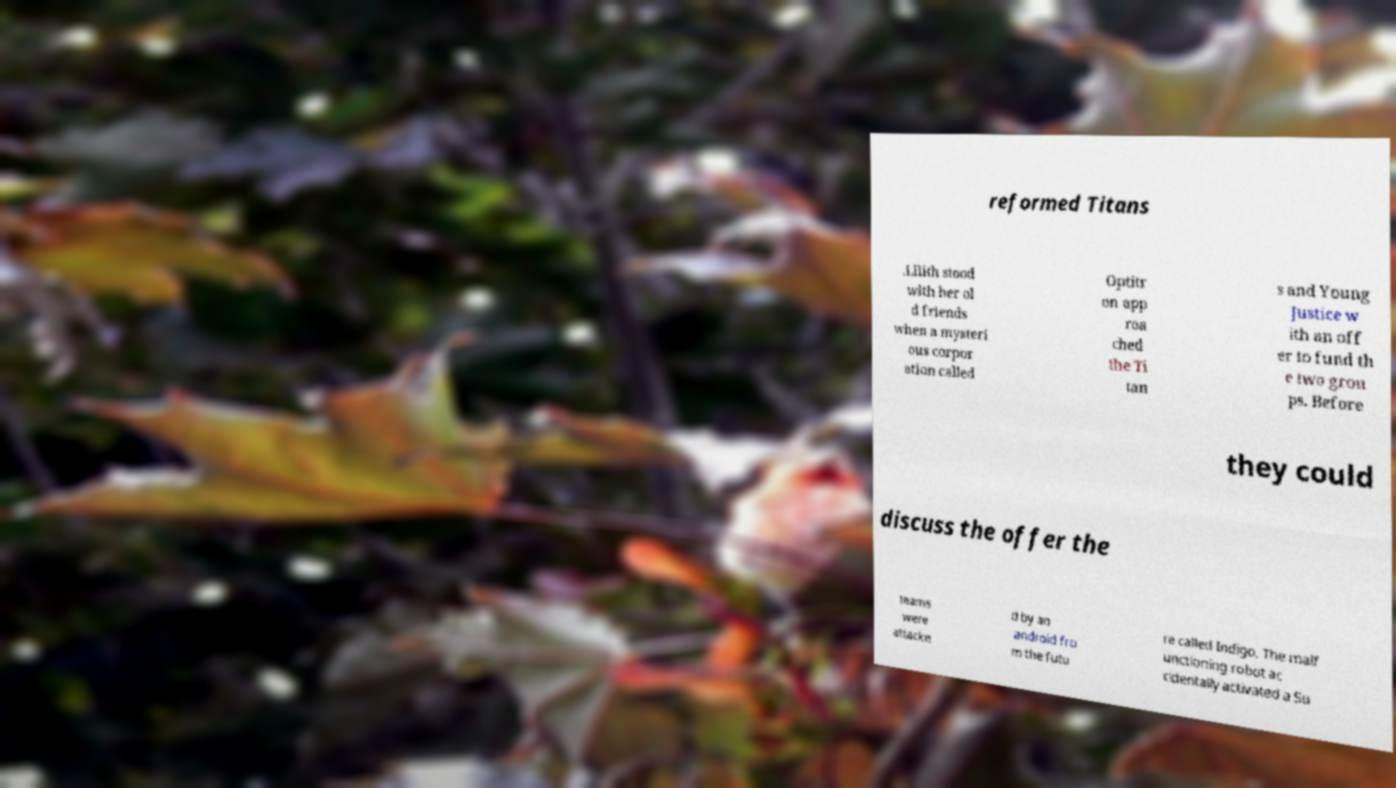Could you extract and type out the text from this image? reformed Titans .Lilith stood with her ol d friends when a mysteri ous corpor ation called Optitr on app roa ched the Ti tan s and Young Justice w ith an off er to fund th e two grou ps. Before they could discuss the offer the teams were attacke d by an android fro m the futu re called Indigo. The malf unctioning robot ac cidentally activated a Su 